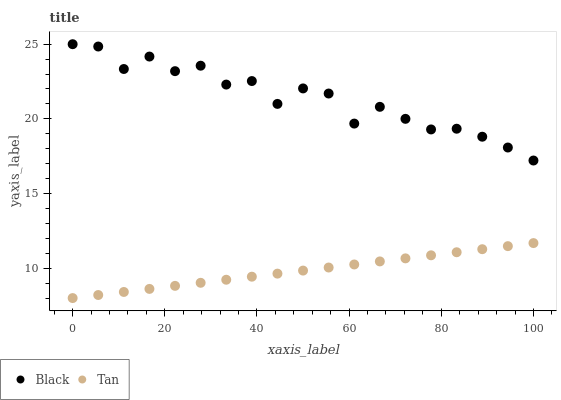Does Tan have the minimum area under the curve?
Answer yes or no. Yes. Does Black have the maximum area under the curve?
Answer yes or no. Yes. Does Black have the minimum area under the curve?
Answer yes or no. No. Is Tan the smoothest?
Answer yes or no. Yes. Is Black the roughest?
Answer yes or no. Yes. Is Black the smoothest?
Answer yes or no. No. Does Tan have the lowest value?
Answer yes or no. Yes. Does Black have the lowest value?
Answer yes or no. No. Does Black have the highest value?
Answer yes or no. Yes. Is Tan less than Black?
Answer yes or no. Yes. Is Black greater than Tan?
Answer yes or no. Yes. Does Tan intersect Black?
Answer yes or no. No. 